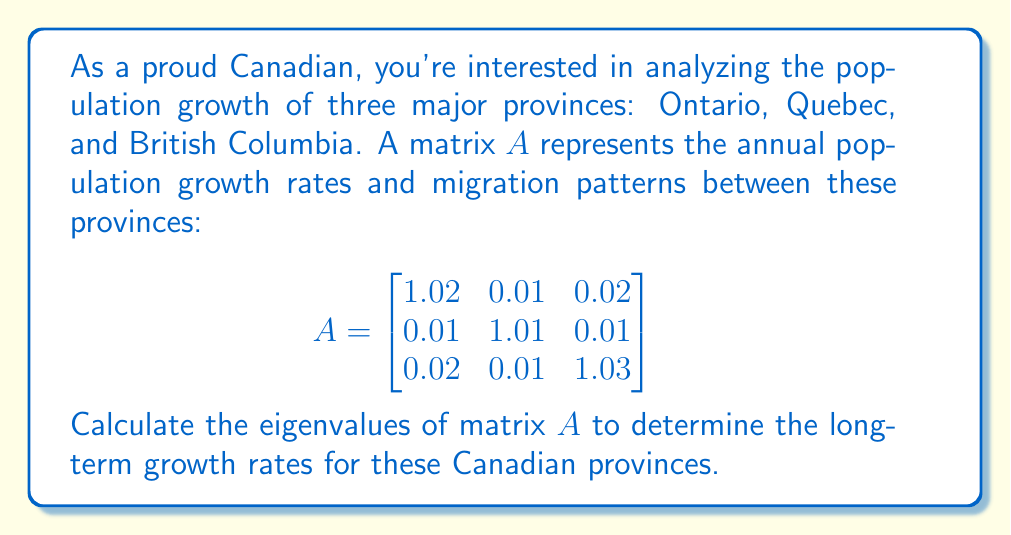Provide a solution to this math problem. To find the eigenvalues of matrix $A$, we need to solve the characteristic equation:

$\det(A - \lambda I) = 0$

Where $I$ is the $3 \times 3$ identity matrix and $\lambda$ represents the eigenvalues.

Step 1: Set up the characteristic equation:
$$\det\begin{pmatrix}
1.02 - \lambda & 0.01 & 0.02 \\
0.01 & 1.01 - \lambda & 0.01 \\
0.02 & 0.01 & 1.03 - \lambda
\end{pmatrix} = 0$$

Step 2: Expand the determinant:
$$(1.02 - \lambda)[(1.01 - \lambda)(1.03 - \lambda) - 0.0001] - 0.01[0.01(1.03 - \lambda) - 0.0002] + 0.02[0.01(0.01) - 0.01(1.01 - \lambda)] = 0$$

Step 3: Simplify and rearrange:
$$\lambda^3 - 3.06\lambda^2 + 3.1208\lambda - 1.061208 = 0$$

Step 4: Use a computer algebra system or numerical methods to solve this cubic equation. The solutions are the eigenvalues:

$\lambda_1 \approx 1.0600054$
$\lambda_2 \approx 1.0000000$
$\lambda_3 \approx 0.9999946$

These eigenvalues represent the long-term growth rates for the Canadian provinces. The largest eigenvalue ($\lambda_1$) indicates the overall growth rate of the system, while the other eigenvalues represent internal dynamics between the provinces.
Answer: The eigenvalues of matrix $A$ are approximately:
$\lambda_1 \approx 1.0600054$
$\lambda_2 \approx 1.0000000$
$\lambda_3 \approx 0.9999946$ 